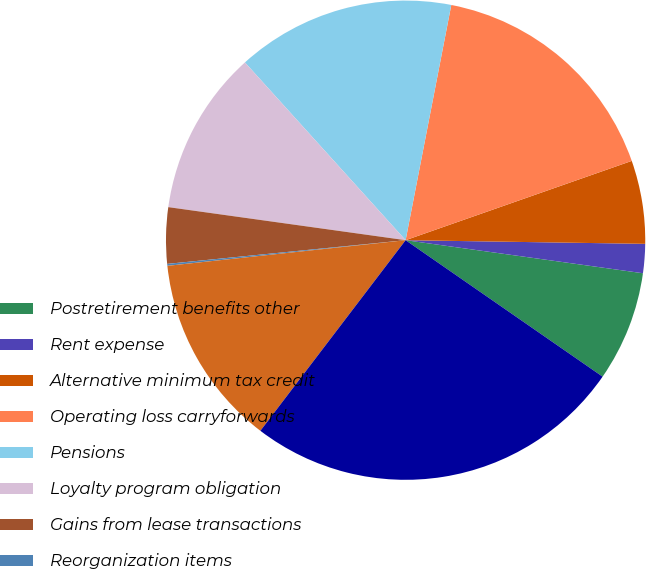<chart> <loc_0><loc_0><loc_500><loc_500><pie_chart><fcel>Postretirement benefits other<fcel>Rent expense<fcel>Alternative minimum tax credit<fcel>Operating loss carryforwards<fcel>Pensions<fcel>Loyalty program obligation<fcel>Gains from lease transactions<fcel>Reorganization items<fcel>Other<fcel>Total deferred tax assets<nl><fcel>7.44%<fcel>1.96%<fcel>5.61%<fcel>16.58%<fcel>14.75%<fcel>11.1%<fcel>3.78%<fcel>0.13%<fcel>12.93%<fcel>25.72%<nl></chart> 